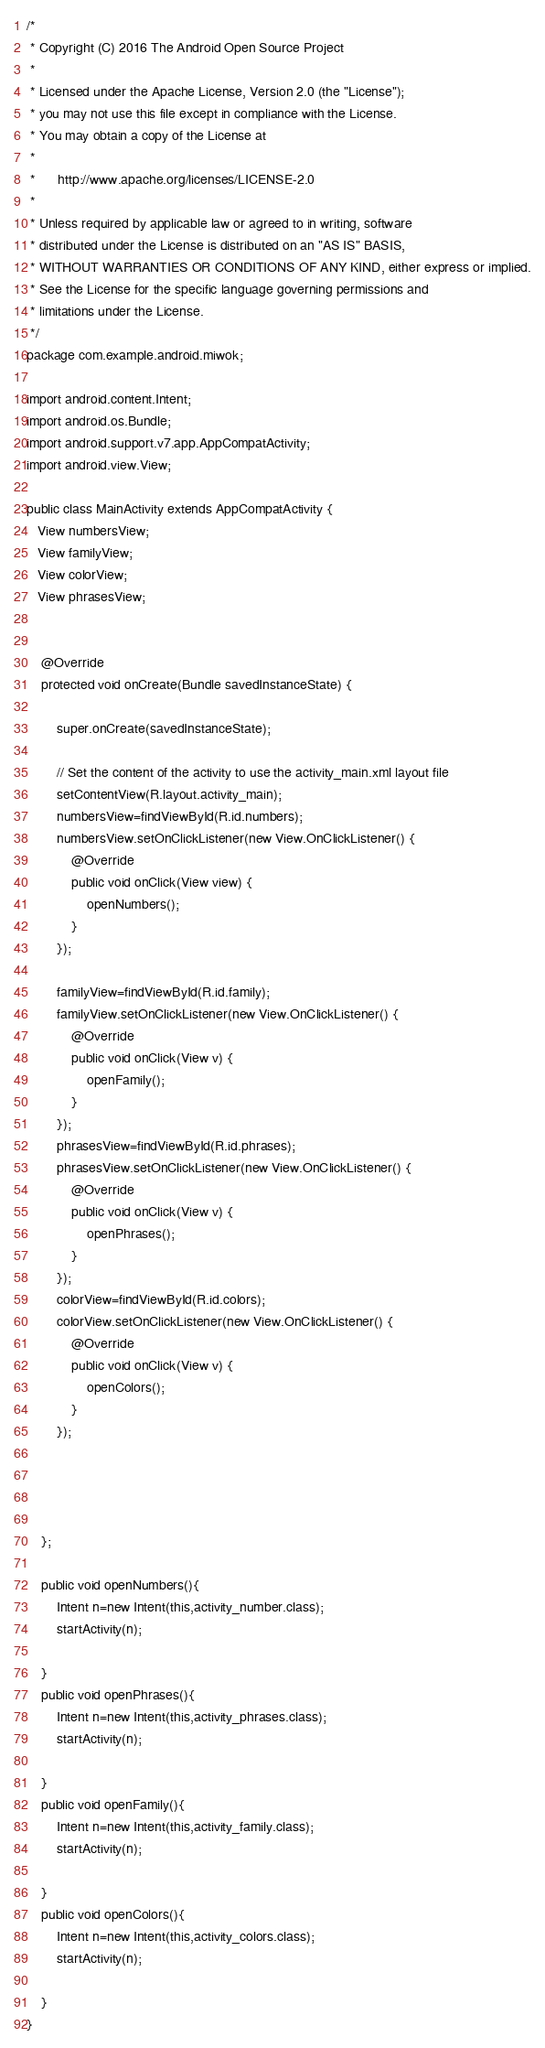<code> <loc_0><loc_0><loc_500><loc_500><_Java_>/*
 * Copyright (C) 2016 The Android Open Source Project
 *
 * Licensed under the Apache License, Version 2.0 (the "License");
 * you may not use this file except in compliance with the License.
 * You may obtain a copy of the License at
 *
 *      http://www.apache.org/licenses/LICENSE-2.0
 *
 * Unless required by applicable law or agreed to in writing, software
 * distributed under the License is distributed on an "AS IS" BASIS,
 * WITHOUT WARRANTIES OR CONDITIONS OF ANY KIND, either express or implied.
 * See the License for the specific language governing permissions and
 * limitations under the License.
 */
package com.example.android.miwok;

import android.content.Intent;
import android.os.Bundle;
import android.support.v7.app.AppCompatActivity;
import android.view.View;

public class MainActivity extends AppCompatActivity {
   View numbersView;
   View familyView;
   View colorView;
   View phrasesView;


    @Override
    protected void onCreate(Bundle savedInstanceState) {

        super.onCreate(savedInstanceState);

        // Set the content of the activity to use the activity_main.xml layout file
        setContentView(R.layout.activity_main);
        numbersView=findViewById(R.id.numbers);
        numbersView.setOnClickListener(new View.OnClickListener() {
            @Override
            public void onClick(View view) {
                openNumbers();
            }
        });

        familyView=findViewById(R.id.family);
        familyView.setOnClickListener(new View.OnClickListener() {
            @Override
            public void onClick(View v) {
                openFamily();
            }
        });
        phrasesView=findViewById(R.id.phrases);
        phrasesView.setOnClickListener(new View.OnClickListener() {
            @Override
            public void onClick(View v) {
                openPhrases();
            }
        });
        colorView=findViewById(R.id.colors);
        colorView.setOnClickListener(new View.OnClickListener() {
            @Override
            public void onClick(View v) {
                openColors();
            }
        });




    };

    public void openNumbers(){
        Intent n=new Intent(this,activity_number.class);
        startActivity(n);

    }
    public void openPhrases(){
        Intent n=new Intent(this,activity_phrases.class);
        startActivity(n);

    }
    public void openFamily(){
        Intent n=new Intent(this,activity_family.class);
        startActivity(n);

    }
    public void openColors(){
        Intent n=new Intent(this,activity_colors.class);
        startActivity(n);

    }
}
</code> 